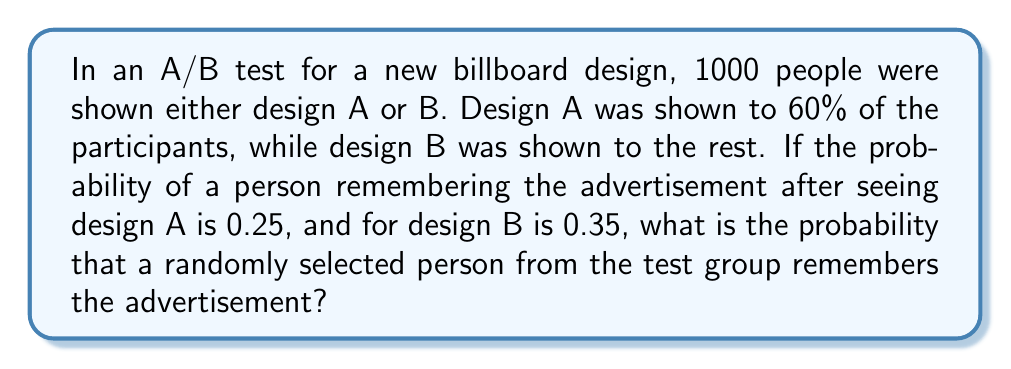Can you answer this question? Let's approach this step-by-step:

1) First, let's define our events:
   A: Person was shown design A
   B: Person was shown design B
   R: Person remembers the advertisement

2) We're given the following probabilities:
   $P(A) = 0.60$ (60% were shown design A)
   $P(B) = 0.40$ (40% were shown design B)
   $P(R|A) = 0.25$ (probability of remembering given design A)
   $P(R|B) = 0.35$ (probability of remembering given design B)

3) We want to find $P(R)$, the overall probability of remembering the ad.

4) We can use the law of total probability:
   $P(R) = P(R|A) \cdot P(A) + P(R|B) \cdot P(B)$

5) Substituting the values:
   $P(R) = 0.25 \cdot 0.60 + 0.35 \cdot 0.40$

6) Calculating:
   $P(R) = 0.15 + 0.14 = 0.29$

Therefore, the probability that a randomly selected person remembers the advertisement is 0.29 or 29%.
Answer: 0.29 